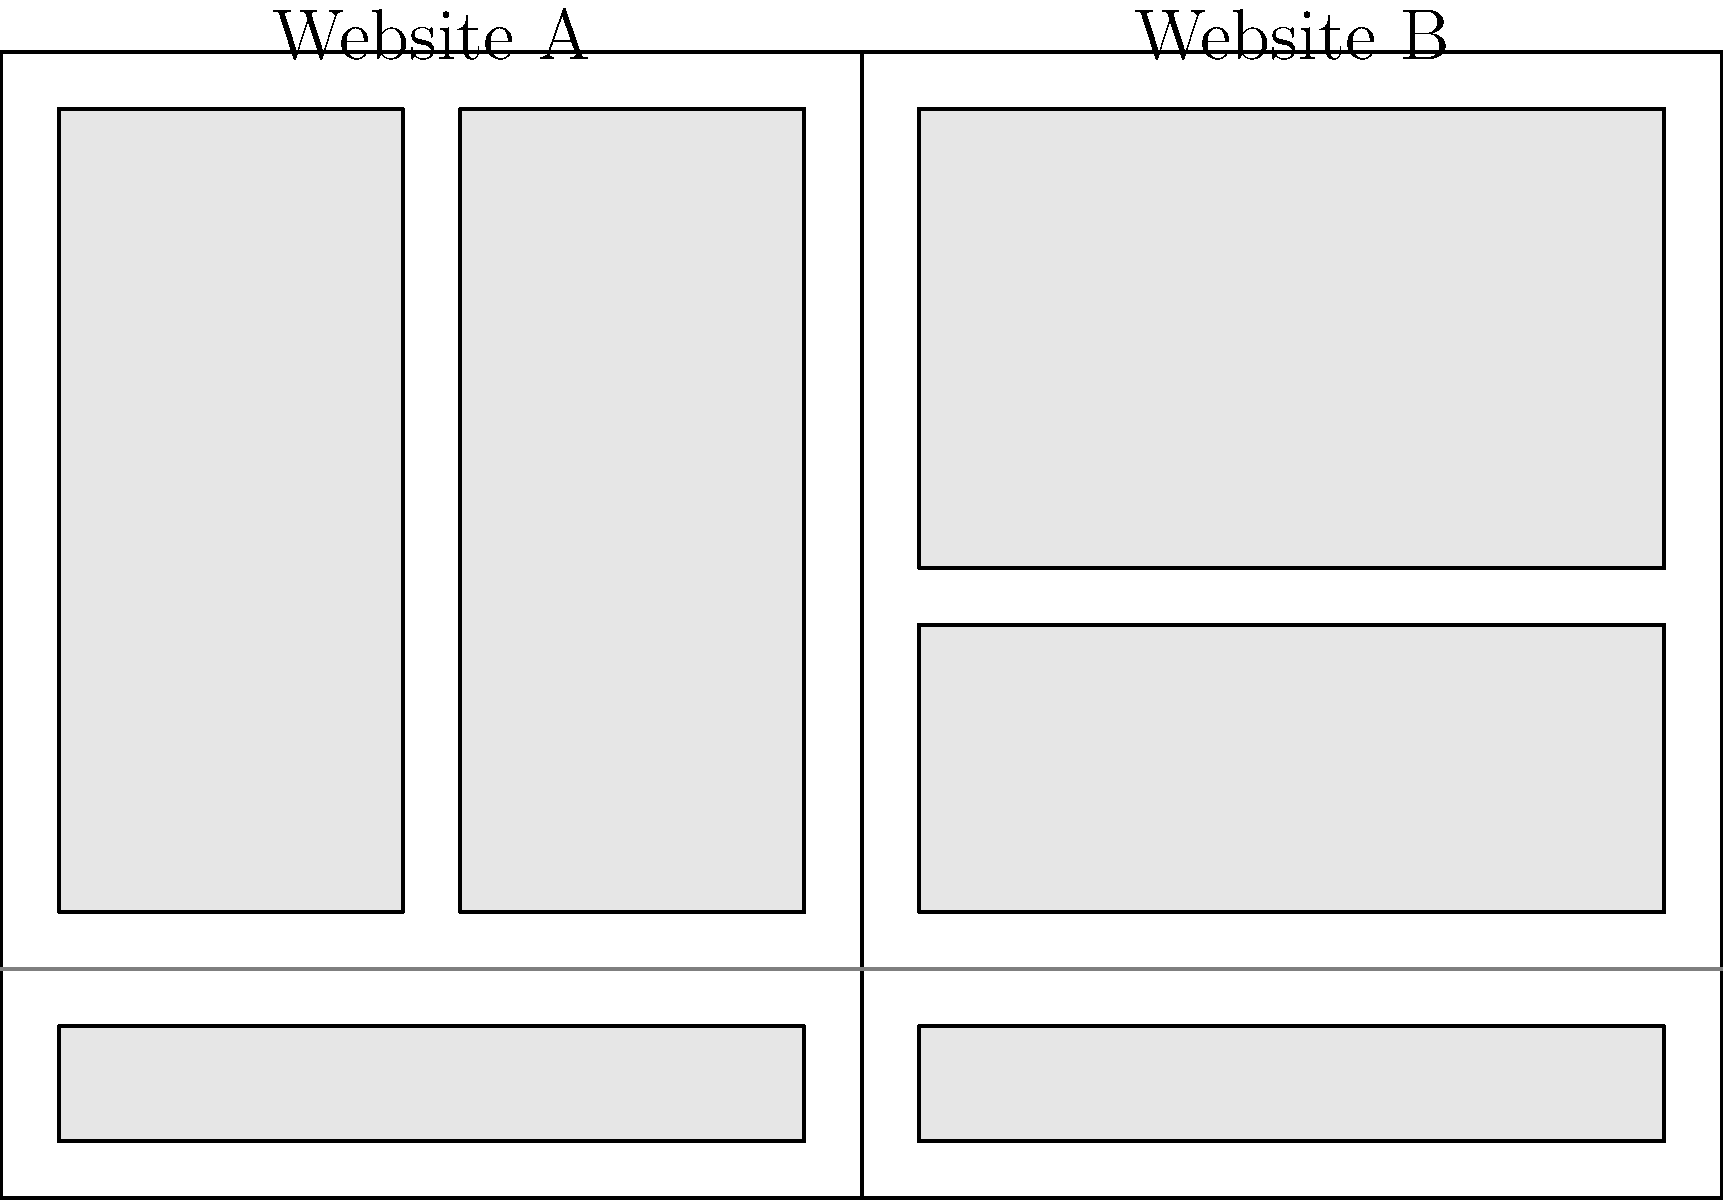As a design blogger collaborating on crossover content, which website layout (A or B) demonstrates a stronger visual hierarchy and why? To determine which website layout has a stronger visual hierarchy, we need to analyze the following aspects:

1. Header prominence:
   Both layouts have similar header sizes, occupying the top portion of the design.

2. Content organization:
   Website A: Uses a two-column layout below the header.
   Website B: Utilizes a single-column layout with two distinct content blocks.

3. Visual flow:
   Website A: The two-column layout may create competition for attention.
   Website B: The single-column layout guides the user's eye from top to bottom.

4. Whitespace usage:
   Website A: Limited whitespace between content areas.
   Website B: More whitespace between content blocks, creating clear separation.

5. Content prioritization:
   Website A: Equal emphasis on both columns, potentially diluting focus.
   Website B: Clear differentiation between content blocks, suggesting a hierarchy of importance.

6. Scalability:
   Website B's layout is more adaptable to different screen sizes and content lengths.

Considering these factors, Website B demonstrates a stronger visual hierarchy because:
- It guides the user's eye more effectively from top to bottom.
- It uses whitespace to create clear separation between content blocks.
- The single-column layout reduces competition for attention.
- It suggests a clearer order of importance for content elements.
Answer: Website B 